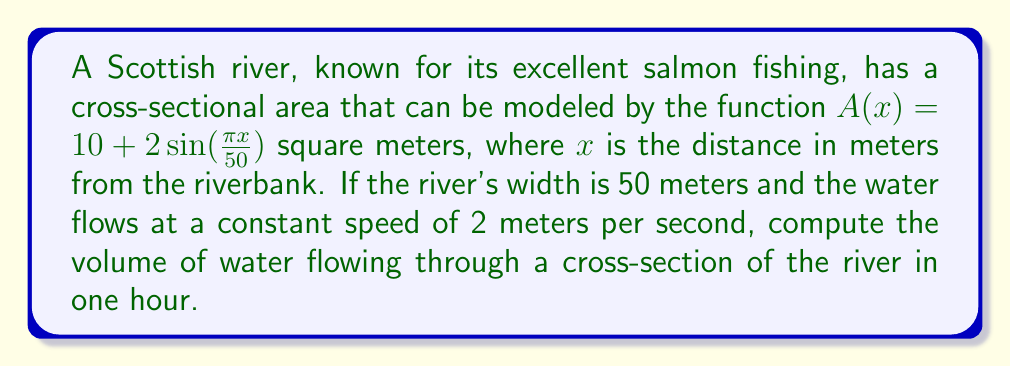Give your solution to this math problem. To solve this problem, we need to follow these steps:

1) First, we need to calculate the total cross-sectional area of the river. This can be done by integrating the given function $A(x)$ over the width of the river.

2) The integral to calculate the area is:

   $$\int_0^{50} (10 + 2\sin(\frac{\pi x}{50})) dx$$

3) Let's solve this integral:

   $$\begin{align}
   \int_0^{50} (10 + 2\sin(\frac{\pi x}{50})) dx &= 10x - \frac{100}{\pi}\cos(\frac{\pi x}{50}) \bigg|_0^{50} \\
   &= (500 - \frac{100}{\pi}\cos(\pi)) - (0 - \frac{100}{\pi}\cos(0)) \\
   &= 500 - \frac{100}{\pi}(-1) - 0 + \frac{100}{\pi} \\
   &= 500 + \frac{200}{\pi}
   \end{align}$$

4) Now that we have the total cross-sectional area, we can calculate the volume of water flowing through in one second by multiplying this area by the speed:

   $$(500 + \frac{200}{\pi}) \cdot 2 = 1000 + \frac{400}{\pi}$$ cubic meters per second

5) To find the volume in one hour, we multiply this by the number of seconds in an hour (3600):

   $$(1000 + \frac{400}{\pi}) \cdot 3600 = 3,600,000 + \frac{1,440,000}{\pi}$$ cubic meters
Answer: The volume of water flowing through a cross-section of the river in one hour is $3,600,000 + \frac{1,440,000}{\pi} \approx 4,058,407.35$ cubic meters. 